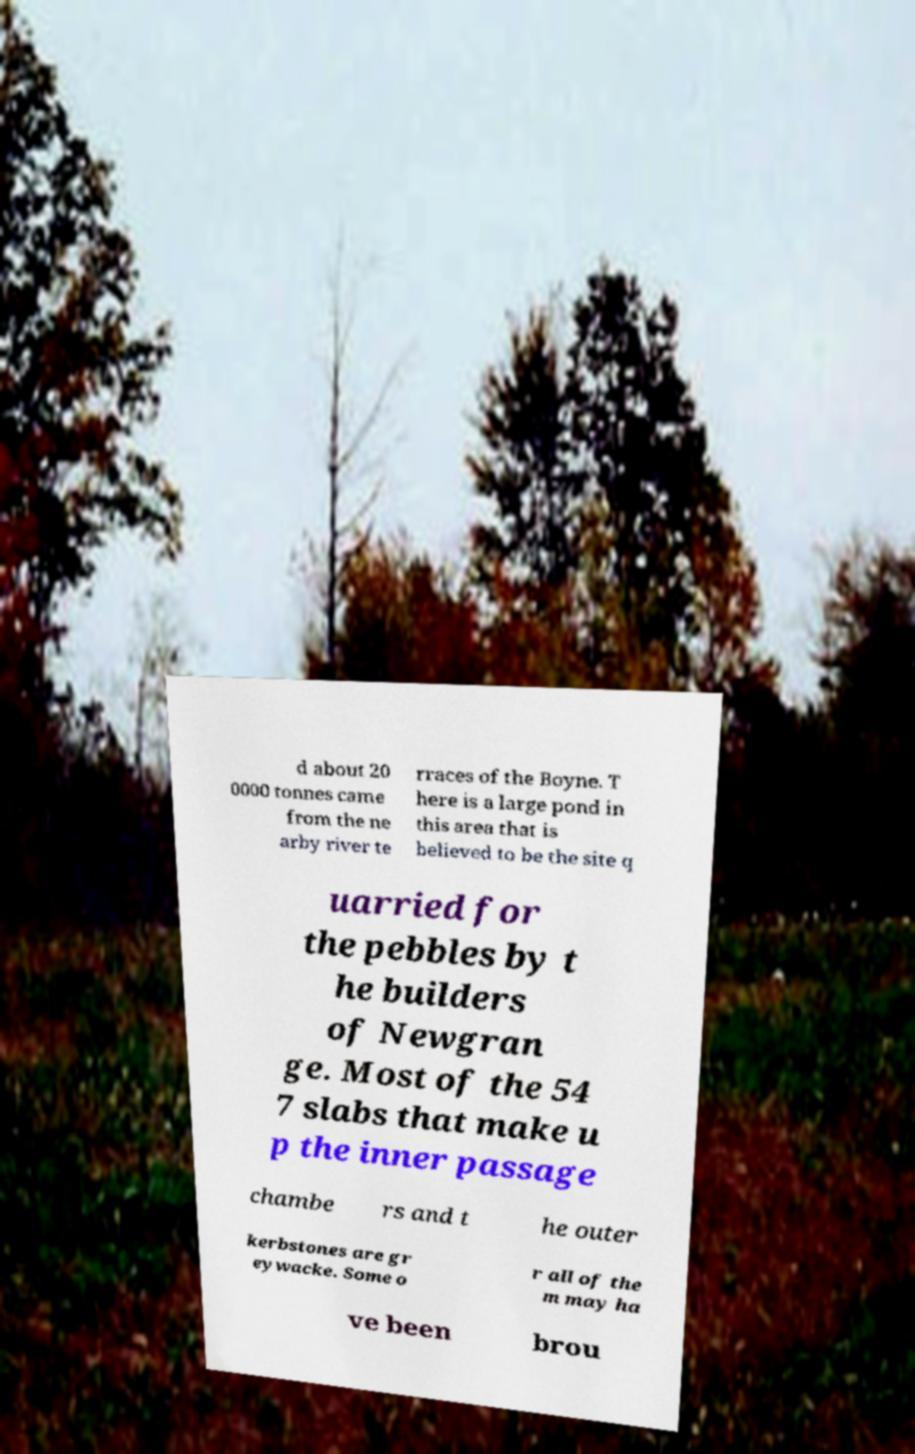Please read and relay the text visible in this image. What does it say? d about 20 0000 tonnes came from the ne arby river te rraces of the Boyne. T here is a large pond in this area that is believed to be the site q uarried for the pebbles by t he builders of Newgran ge. Most of the 54 7 slabs that make u p the inner passage chambe rs and t he outer kerbstones are gr eywacke. Some o r all of the m may ha ve been brou 